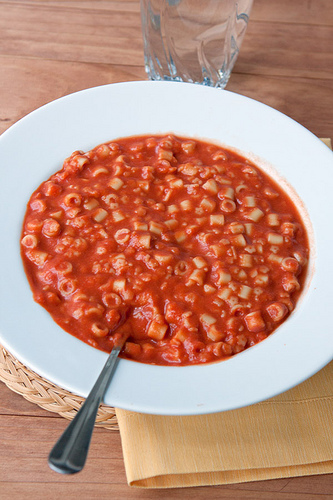<image>
Is the food under the glass? No. The food is not positioned under the glass. The vertical relationship between these objects is different. Where is the spoon in relation to the bowl? Is it under the bowl? No. The spoon is not positioned under the bowl. The vertical relationship between these objects is different. Where is the pasta in relation to the glass? Is it in front of the glass? Yes. The pasta is positioned in front of the glass, appearing closer to the camera viewpoint. 